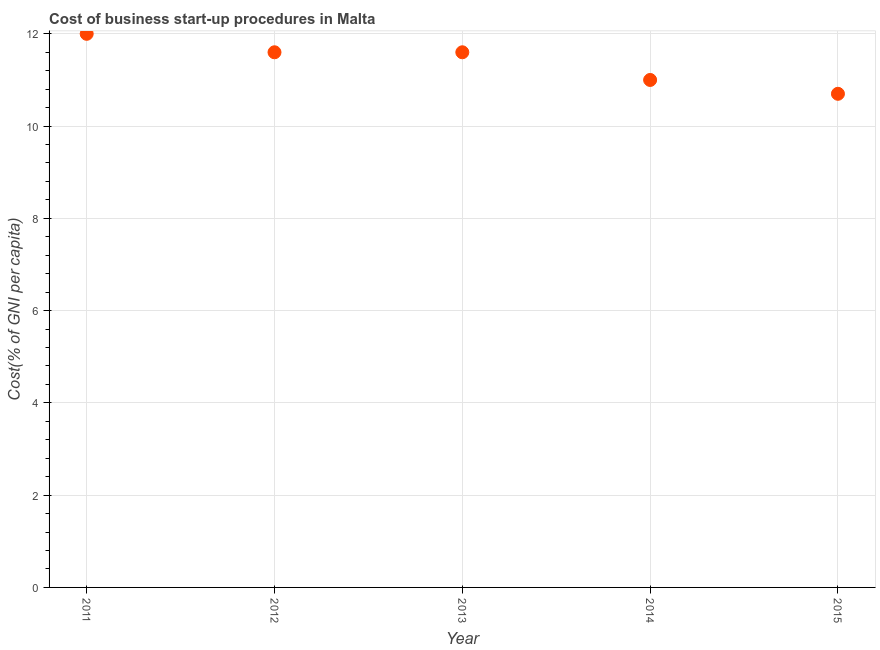Across all years, what is the maximum cost of business startup procedures?
Provide a succinct answer. 12. In which year was the cost of business startup procedures maximum?
Give a very brief answer. 2011. In which year was the cost of business startup procedures minimum?
Offer a very short reply. 2015. What is the sum of the cost of business startup procedures?
Ensure brevity in your answer.  56.9. What is the difference between the cost of business startup procedures in 2013 and 2014?
Your response must be concise. 0.6. What is the average cost of business startup procedures per year?
Make the answer very short. 11.38. What is the median cost of business startup procedures?
Make the answer very short. 11.6. In how many years, is the cost of business startup procedures greater than 8.4 %?
Provide a short and direct response. 5. Do a majority of the years between 2012 and 2014 (inclusive) have cost of business startup procedures greater than 4.8 %?
Provide a short and direct response. Yes. What is the ratio of the cost of business startup procedures in 2011 to that in 2015?
Your answer should be very brief. 1.12. What is the difference between the highest and the second highest cost of business startup procedures?
Your answer should be very brief. 0.4. What is the difference between the highest and the lowest cost of business startup procedures?
Offer a very short reply. 1.3. In how many years, is the cost of business startup procedures greater than the average cost of business startup procedures taken over all years?
Ensure brevity in your answer.  3. How many dotlines are there?
Your answer should be compact. 1. What is the difference between two consecutive major ticks on the Y-axis?
Give a very brief answer. 2. Does the graph contain any zero values?
Your answer should be compact. No. Does the graph contain grids?
Offer a terse response. Yes. What is the title of the graph?
Provide a short and direct response. Cost of business start-up procedures in Malta. What is the label or title of the Y-axis?
Your answer should be compact. Cost(% of GNI per capita). What is the Cost(% of GNI per capita) in 2011?
Give a very brief answer. 12. What is the Cost(% of GNI per capita) in 2012?
Your answer should be very brief. 11.6. What is the Cost(% of GNI per capita) in 2013?
Provide a succinct answer. 11.6. What is the difference between the Cost(% of GNI per capita) in 2011 and 2012?
Your answer should be very brief. 0.4. What is the difference between the Cost(% of GNI per capita) in 2011 and 2014?
Your response must be concise. 1. What is the difference between the Cost(% of GNI per capita) in 2012 and 2013?
Offer a very short reply. 0. What is the difference between the Cost(% of GNI per capita) in 2012 and 2015?
Offer a very short reply. 0.9. What is the difference between the Cost(% of GNI per capita) in 2013 and 2015?
Offer a very short reply. 0.9. What is the difference between the Cost(% of GNI per capita) in 2014 and 2015?
Give a very brief answer. 0.3. What is the ratio of the Cost(% of GNI per capita) in 2011 to that in 2012?
Offer a very short reply. 1.03. What is the ratio of the Cost(% of GNI per capita) in 2011 to that in 2013?
Keep it short and to the point. 1.03. What is the ratio of the Cost(% of GNI per capita) in 2011 to that in 2014?
Your answer should be very brief. 1.09. What is the ratio of the Cost(% of GNI per capita) in 2011 to that in 2015?
Make the answer very short. 1.12. What is the ratio of the Cost(% of GNI per capita) in 2012 to that in 2013?
Provide a succinct answer. 1. What is the ratio of the Cost(% of GNI per capita) in 2012 to that in 2014?
Your answer should be very brief. 1.05. What is the ratio of the Cost(% of GNI per capita) in 2012 to that in 2015?
Your answer should be very brief. 1.08. What is the ratio of the Cost(% of GNI per capita) in 2013 to that in 2014?
Your answer should be very brief. 1.05. What is the ratio of the Cost(% of GNI per capita) in 2013 to that in 2015?
Offer a terse response. 1.08. What is the ratio of the Cost(% of GNI per capita) in 2014 to that in 2015?
Provide a short and direct response. 1.03. 